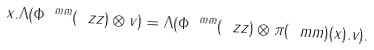Convert formula to latex. <formula><loc_0><loc_0><loc_500><loc_500>x . \Lambda ( \Phi ^ { \ m m } ( \ z z ) \otimes v ) = \Lambda ( \Phi ^ { \ m m } ( \ z z ) \otimes \pi ( \ m m ) ( x ) . v ) .</formula> 